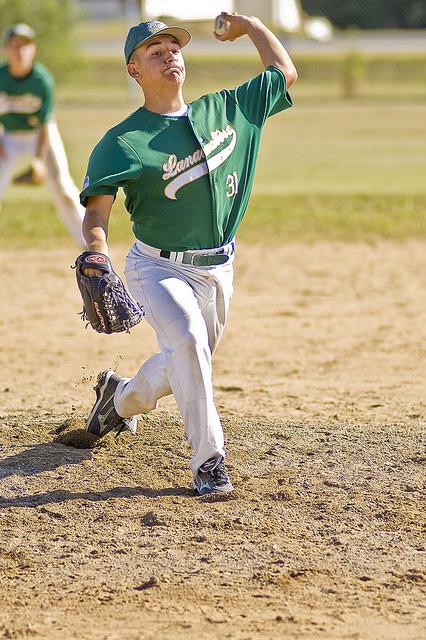What brand of glove is the player using?
Quick response, please. Nike. What color shirt is the player wearing?
Concise answer only. Green. What is the man's dominant hand?
Give a very brief answer. Left. 